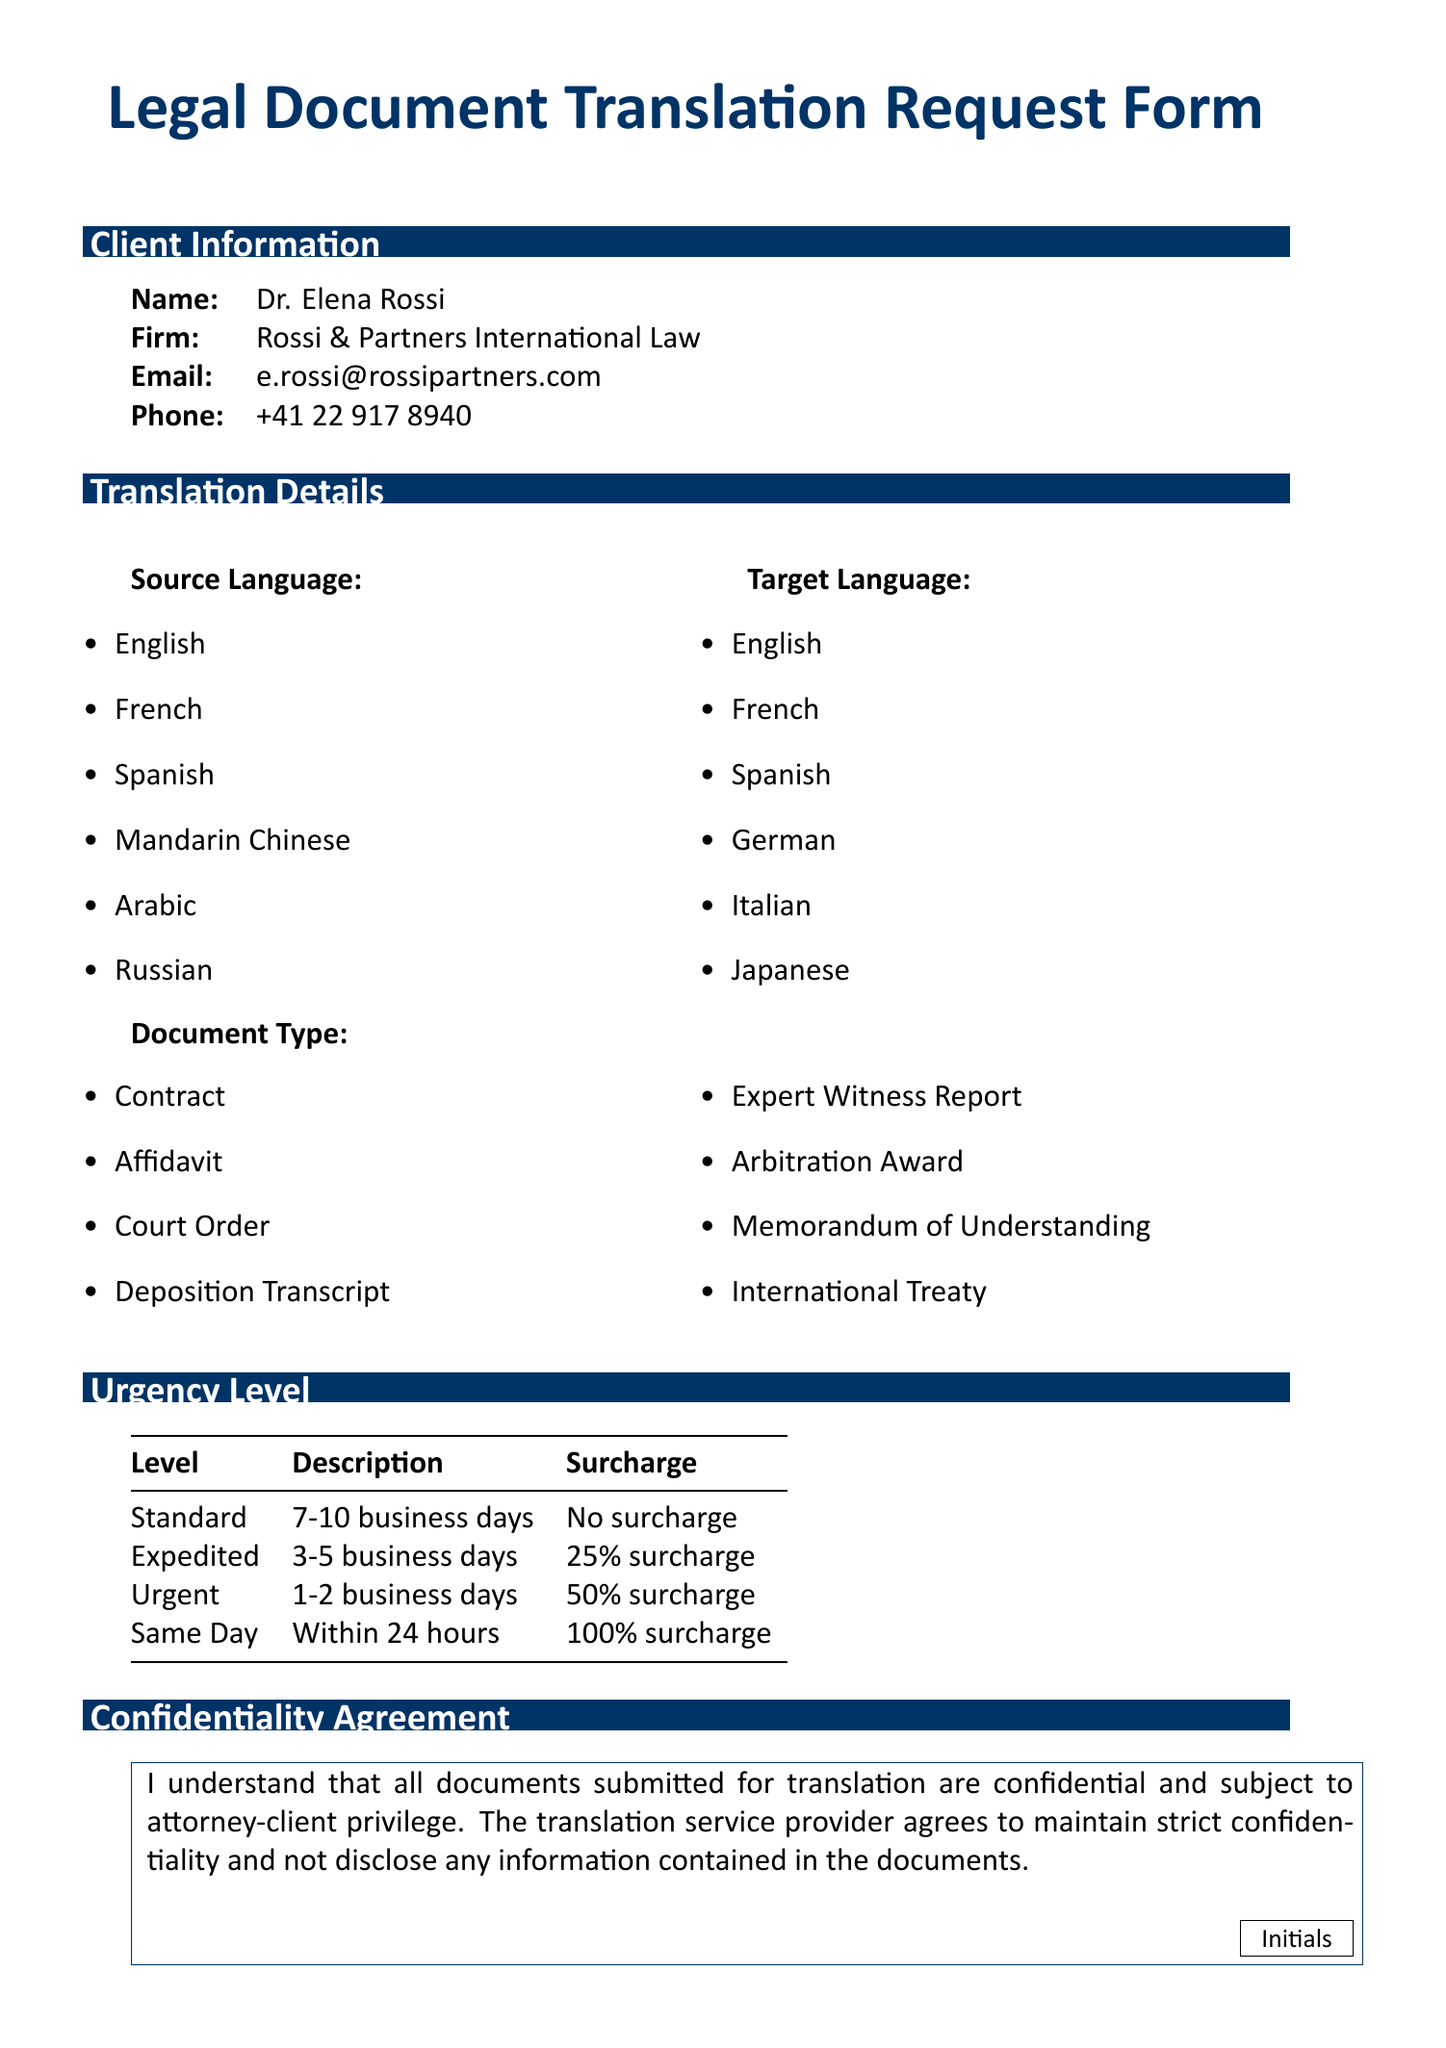what is the name of the client? The client's name is provided in the document under client information.
Answer: Dr. Elena Rossi what is the email address of the client? The email address is listed in the client information section of the document.
Answer: e.rossi@rossipartners.com what is the urgency level for "Same Day"? The urgency level provides a description alongside a surcharge for the service the client needs.
Answer: Within 24 hours how many business days does the "Expedited" service take? This is stated in the urgency level section describing the time frame for expedited service.
Answer: 3-5 business days which payment option does not involve immediate electronic payment? This question targets the payment options provided in the document and seeks a specific type.
Answer: Law Firm Account name one type of document that can be translated according to this form. The document outlines various types of legal documents that are eligible for translation.
Answer: Contract what is the surcharge for an urgent translation request? The surcharge for the urgency level is mentioned in the respective section related to urgency.
Answer: 50% surcharge is acceptance of the confidentiality agreement required? The confidentiality agreement indicates the requirement for client acknowledgment within the form.
Answer: Yes what delivery method ensures secure communication? The document lists various delivery methods, one of which ensures security for sharing translations.
Answer: Secure Email 